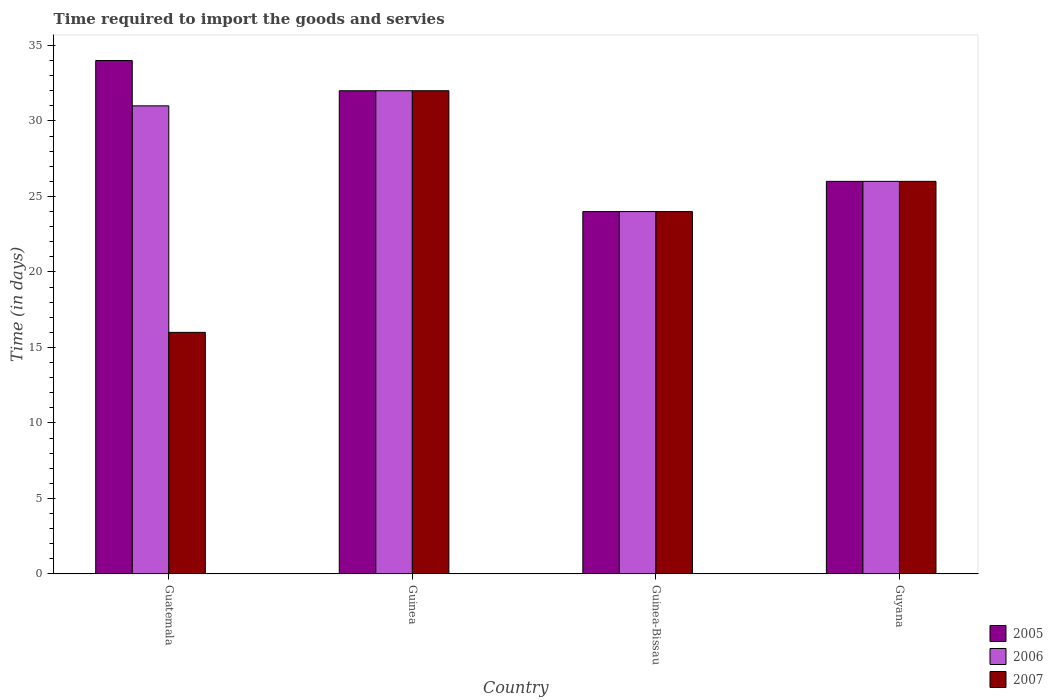How many different coloured bars are there?
Your answer should be very brief. 3. How many groups of bars are there?
Offer a terse response. 4. Are the number of bars per tick equal to the number of legend labels?
Your answer should be very brief. Yes. What is the label of the 3rd group of bars from the left?
Provide a succinct answer. Guinea-Bissau. What is the number of days required to import the goods and services in 2007 in Guatemala?
Your answer should be compact. 16. Across all countries, what is the minimum number of days required to import the goods and services in 2006?
Provide a short and direct response. 24. In which country was the number of days required to import the goods and services in 2007 maximum?
Your response must be concise. Guinea. In which country was the number of days required to import the goods and services in 2005 minimum?
Your response must be concise. Guinea-Bissau. What is the total number of days required to import the goods and services in 2005 in the graph?
Your answer should be very brief. 116. What is the difference between the number of days required to import the goods and services in 2007 in Guinea and that in Guyana?
Provide a succinct answer. 6. What is the difference between the number of days required to import the goods and services in 2007 in Guinea-Bissau and the number of days required to import the goods and services in 2005 in Guinea?
Your answer should be very brief. -8. What is the average number of days required to import the goods and services in 2007 per country?
Keep it short and to the point. 24.5. In how many countries, is the number of days required to import the goods and services in 2006 greater than 15 days?
Offer a very short reply. 4. What is the ratio of the number of days required to import the goods and services in 2006 in Guatemala to that in Guinea?
Provide a short and direct response. 0.97. Is the number of days required to import the goods and services in 2005 in Guinea less than that in Guinea-Bissau?
Ensure brevity in your answer.  No. Is the difference between the number of days required to import the goods and services in 2007 in Guatemala and Guinea-Bissau greater than the difference between the number of days required to import the goods and services in 2006 in Guatemala and Guinea-Bissau?
Your response must be concise. No. What is the difference between the highest and the second highest number of days required to import the goods and services in 2005?
Offer a terse response. -2. What is the difference between the highest and the lowest number of days required to import the goods and services in 2005?
Offer a terse response. 10. In how many countries, is the number of days required to import the goods and services in 2007 greater than the average number of days required to import the goods and services in 2007 taken over all countries?
Make the answer very short. 2. Is the sum of the number of days required to import the goods and services in 2005 in Guatemala and Guinea greater than the maximum number of days required to import the goods and services in 2006 across all countries?
Keep it short and to the point. Yes. What does the 3rd bar from the left in Guyana represents?
Offer a terse response. 2007. What does the 3rd bar from the right in Guinea-Bissau represents?
Offer a very short reply. 2005. Is it the case that in every country, the sum of the number of days required to import the goods and services in 2007 and number of days required to import the goods and services in 2005 is greater than the number of days required to import the goods and services in 2006?
Offer a terse response. Yes. What is the difference between two consecutive major ticks on the Y-axis?
Offer a terse response. 5. Are the values on the major ticks of Y-axis written in scientific E-notation?
Keep it short and to the point. No. Does the graph contain any zero values?
Provide a succinct answer. No. Does the graph contain grids?
Offer a terse response. No. Where does the legend appear in the graph?
Make the answer very short. Bottom right. How are the legend labels stacked?
Provide a succinct answer. Vertical. What is the title of the graph?
Keep it short and to the point. Time required to import the goods and servies. Does "1962" appear as one of the legend labels in the graph?
Give a very brief answer. No. What is the label or title of the X-axis?
Ensure brevity in your answer.  Country. What is the label or title of the Y-axis?
Provide a short and direct response. Time (in days). What is the Time (in days) in 2006 in Guatemala?
Your answer should be very brief. 31. What is the Time (in days) of 2007 in Guatemala?
Offer a terse response. 16. What is the Time (in days) in 2007 in Guinea?
Provide a succinct answer. 32. What is the Time (in days) in 2005 in Guinea-Bissau?
Your answer should be compact. 24. What is the Time (in days) in 2006 in Guinea-Bissau?
Your answer should be very brief. 24. What is the Time (in days) of 2007 in Guinea-Bissau?
Keep it short and to the point. 24. What is the Time (in days) of 2006 in Guyana?
Offer a terse response. 26. Across all countries, what is the maximum Time (in days) of 2005?
Offer a terse response. 34. Across all countries, what is the maximum Time (in days) of 2007?
Your answer should be compact. 32. Across all countries, what is the minimum Time (in days) in 2005?
Make the answer very short. 24. Across all countries, what is the minimum Time (in days) of 2007?
Ensure brevity in your answer.  16. What is the total Time (in days) in 2005 in the graph?
Make the answer very short. 116. What is the total Time (in days) in 2006 in the graph?
Give a very brief answer. 113. What is the difference between the Time (in days) of 2005 in Guatemala and that in Guinea?
Make the answer very short. 2. What is the difference between the Time (in days) of 2006 in Guatemala and that in Guinea?
Your answer should be compact. -1. What is the difference between the Time (in days) of 2007 in Guatemala and that in Guinea-Bissau?
Your response must be concise. -8. What is the difference between the Time (in days) in 2005 in Guatemala and that in Guyana?
Your answer should be compact. 8. What is the difference between the Time (in days) of 2006 in Guatemala and that in Guyana?
Ensure brevity in your answer.  5. What is the difference between the Time (in days) of 2006 in Guinea and that in Guinea-Bissau?
Your answer should be very brief. 8. What is the difference between the Time (in days) in 2006 in Guinea and that in Guyana?
Provide a short and direct response. 6. What is the difference between the Time (in days) in 2005 in Guinea-Bissau and that in Guyana?
Make the answer very short. -2. What is the difference between the Time (in days) in 2007 in Guinea-Bissau and that in Guyana?
Your response must be concise. -2. What is the difference between the Time (in days) in 2005 in Guatemala and the Time (in days) in 2006 in Guinea?
Make the answer very short. 2. What is the difference between the Time (in days) in 2005 in Guatemala and the Time (in days) in 2007 in Guinea?
Your answer should be compact. 2. What is the difference between the Time (in days) of 2005 in Guatemala and the Time (in days) of 2006 in Guyana?
Your answer should be compact. 8. What is the difference between the Time (in days) in 2006 in Guatemala and the Time (in days) in 2007 in Guyana?
Your response must be concise. 5. What is the difference between the Time (in days) in 2005 in Guinea and the Time (in days) in 2006 in Guinea-Bissau?
Offer a very short reply. 8. What is the difference between the Time (in days) of 2006 in Guinea and the Time (in days) of 2007 in Guinea-Bissau?
Provide a short and direct response. 8. What is the difference between the Time (in days) of 2005 in Guinea and the Time (in days) of 2007 in Guyana?
Give a very brief answer. 6. What is the difference between the Time (in days) in 2006 in Guinea and the Time (in days) in 2007 in Guyana?
Give a very brief answer. 6. What is the difference between the Time (in days) in 2005 in Guinea-Bissau and the Time (in days) in 2006 in Guyana?
Make the answer very short. -2. What is the difference between the Time (in days) of 2005 in Guinea-Bissau and the Time (in days) of 2007 in Guyana?
Ensure brevity in your answer.  -2. What is the average Time (in days) of 2006 per country?
Give a very brief answer. 28.25. What is the average Time (in days) in 2007 per country?
Ensure brevity in your answer.  24.5. What is the difference between the Time (in days) of 2005 and Time (in days) of 2006 in Guatemala?
Offer a terse response. 3. What is the difference between the Time (in days) of 2005 and Time (in days) of 2007 in Guinea?
Your answer should be compact. 0. What is the difference between the Time (in days) of 2005 and Time (in days) of 2006 in Guinea-Bissau?
Make the answer very short. 0. What is the difference between the Time (in days) of 2006 and Time (in days) of 2007 in Guyana?
Provide a succinct answer. 0. What is the ratio of the Time (in days) in 2005 in Guatemala to that in Guinea?
Your answer should be very brief. 1.06. What is the ratio of the Time (in days) in 2006 in Guatemala to that in Guinea?
Make the answer very short. 0.97. What is the ratio of the Time (in days) in 2005 in Guatemala to that in Guinea-Bissau?
Your response must be concise. 1.42. What is the ratio of the Time (in days) of 2006 in Guatemala to that in Guinea-Bissau?
Give a very brief answer. 1.29. What is the ratio of the Time (in days) of 2007 in Guatemala to that in Guinea-Bissau?
Provide a short and direct response. 0.67. What is the ratio of the Time (in days) of 2005 in Guatemala to that in Guyana?
Your answer should be very brief. 1.31. What is the ratio of the Time (in days) of 2006 in Guatemala to that in Guyana?
Keep it short and to the point. 1.19. What is the ratio of the Time (in days) of 2007 in Guatemala to that in Guyana?
Give a very brief answer. 0.62. What is the ratio of the Time (in days) of 2005 in Guinea to that in Guinea-Bissau?
Provide a short and direct response. 1.33. What is the ratio of the Time (in days) of 2006 in Guinea to that in Guinea-Bissau?
Provide a short and direct response. 1.33. What is the ratio of the Time (in days) in 2007 in Guinea to that in Guinea-Bissau?
Make the answer very short. 1.33. What is the ratio of the Time (in days) in 2005 in Guinea to that in Guyana?
Your answer should be very brief. 1.23. What is the ratio of the Time (in days) of 2006 in Guinea to that in Guyana?
Give a very brief answer. 1.23. What is the ratio of the Time (in days) in 2007 in Guinea to that in Guyana?
Give a very brief answer. 1.23. What is the ratio of the Time (in days) in 2005 in Guinea-Bissau to that in Guyana?
Keep it short and to the point. 0.92. What is the ratio of the Time (in days) in 2006 in Guinea-Bissau to that in Guyana?
Provide a succinct answer. 0.92. What is the ratio of the Time (in days) in 2007 in Guinea-Bissau to that in Guyana?
Offer a terse response. 0.92. What is the difference between the highest and the second highest Time (in days) in 2007?
Ensure brevity in your answer.  6. What is the difference between the highest and the lowest Time (in days) of 2005?
Offer a very short reply. 10. 